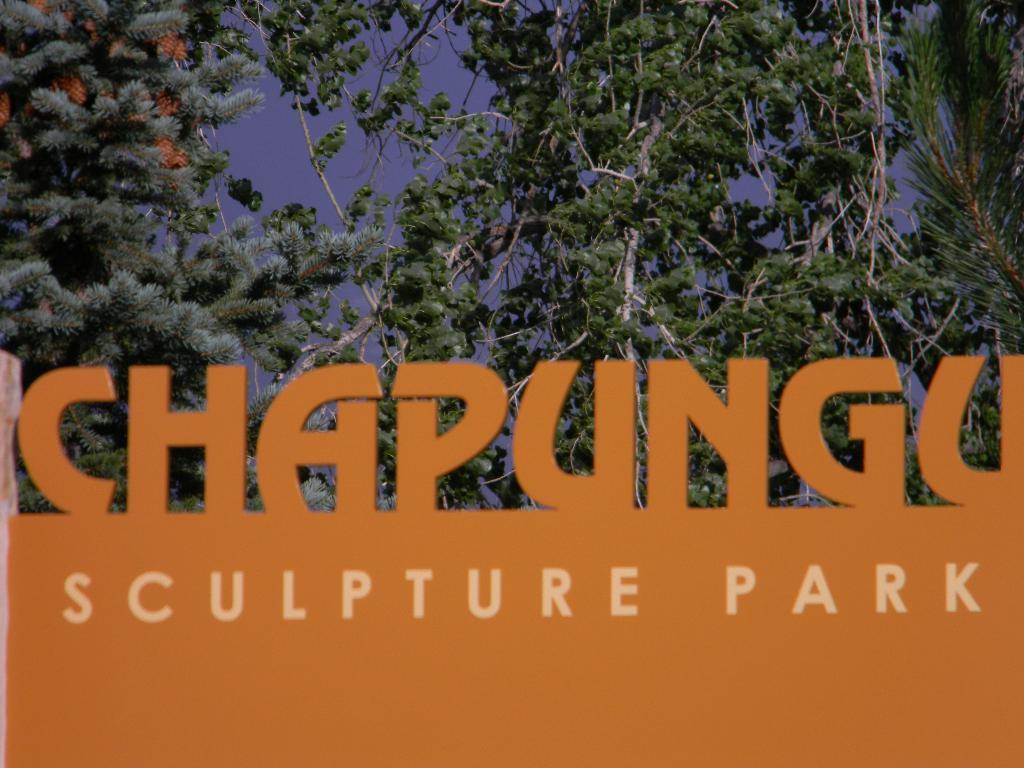What is the main object in the image? There is a board in the image. What can be seen in the background of the image? There are trees and the sky visible in the background of the image. Can you describe the fight between the kittens in the image? There are no kittens or fights present in the image; it only features a board and trees in the background. 